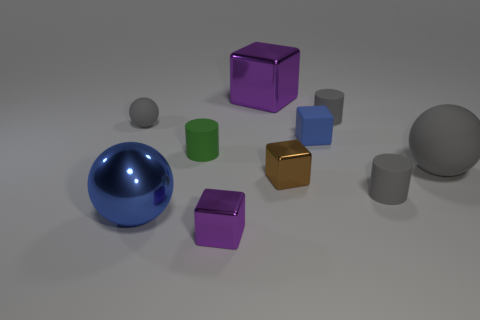Subtract all big cubes. How many cubes are left? 3 Subtract all gray spheres. How many spheres are left? 1 Subtract 3 cylinders. How many cylinders are left? 0 Subtract all blocks. How many objects are left? 6 Subtract all big gray rubber balls. Subtract all tiny rubber spheres. How many objects are left? 8 Add 1 purple metal cubes. How many purple metal cubes are left? 3 Add 7 large gray rubber balls. How many large gray rubber balls exist? 8 Subtract 0 gray blocks. How many objects are left? 10 Subtract all brown spheres. Subtract all gray cylinders. How many spheres are left? 3 Subtract all blue cylinders. How many blue spheres are left? 1 